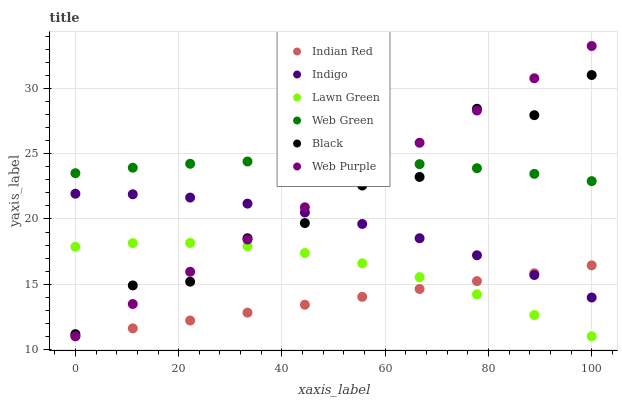Does Indian Red have the minimum area under the curve?
Answer yes or no. Yes. Does Web Green have the maximum area under the curve?
Answer yes or no. Yes. Does Indigo have the minimum area under the curve?
Answer yes or no. No. Does Indigo have the maximum area under the curve?
Answer yes or no. No. Is Web Purple the smoothest?
Answer yes or no. Yes. Is Black the roughest?
Answer yes or no. Yes. Is Indigo the smoothest?
Answer yes or no. No. Is Indigo the roughest?
Answer yes or no. No. Does Lawn Green have the lowest value?
Answer yes or no. Yes. Does Indigo have the lowest value?
Answer yes or no. No. Does Web Purple have the highest value?
Answer yes or no. Yes. Does Indigo have the highest value?
Answer yes or no. No. Is Lawn Green less than Web Green?
Answer yes or no. Yes. Is Black greater than Indian Red?
Answer yes or no. Yes. Does Indigo intersect Web Purple?
Answer yes or no. Yes. Is Indigo less than Web Purple?
Answer yes or no. No. Is Indigo greater than Web Purple?
Answer yes or no. No. Does Lawn Green intersect Web Green?
Answer yes or no. No. 